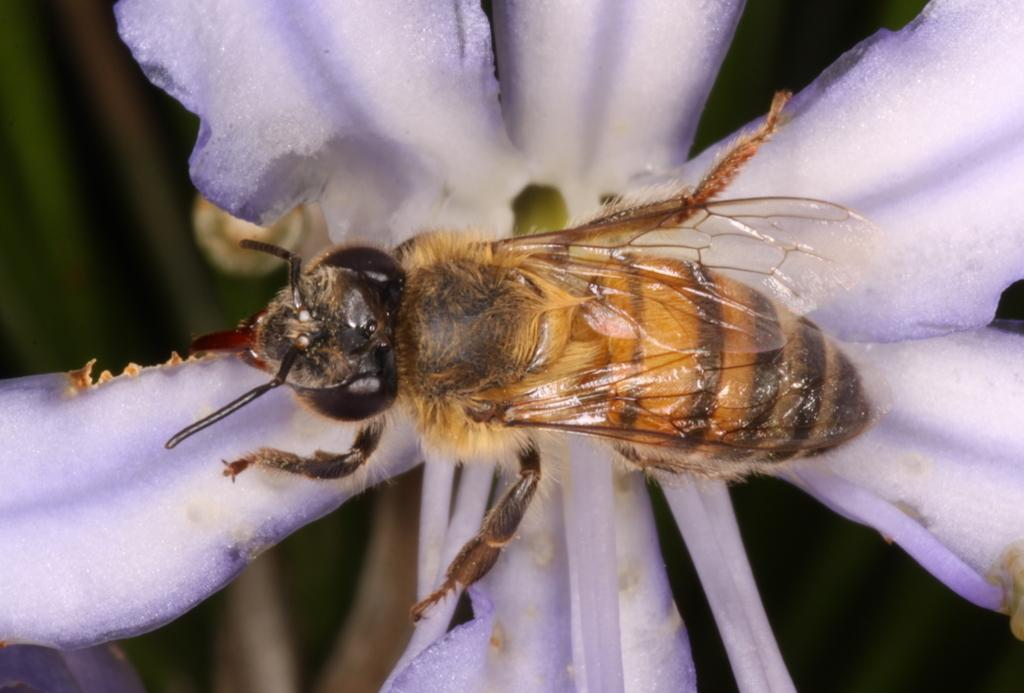What type of insect is present in the image? There is a honey bee in the image. What is the honey bee doing in the image? The honey bee is on a violet-colored flower. Where is the store located in the image? There is no store present in the image; it features a honey bee on a violet-colored flower. Can you see a squirrel or cub in the image? There is no squirrel or cub present in the image. 